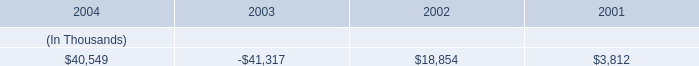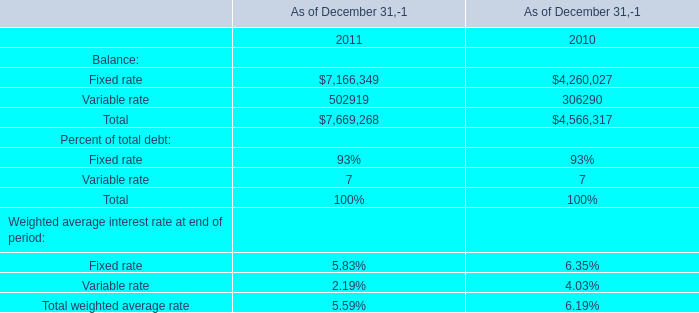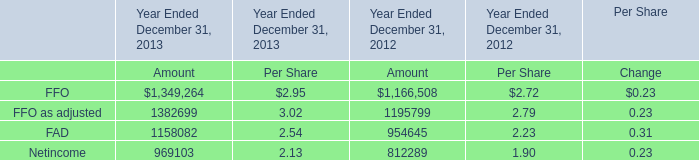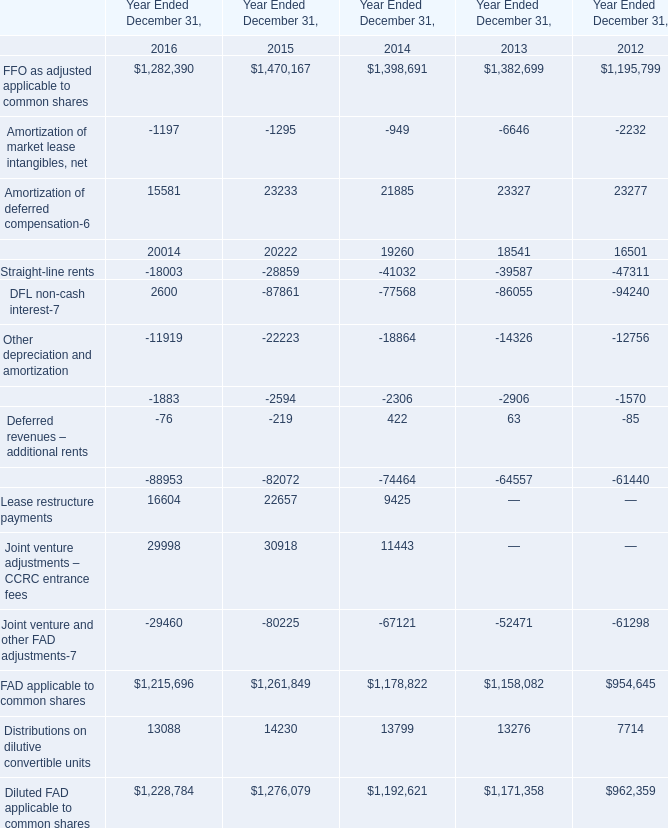Which year is FFO as adjusted applicable to common shares the most? 
Answer: 2015. 